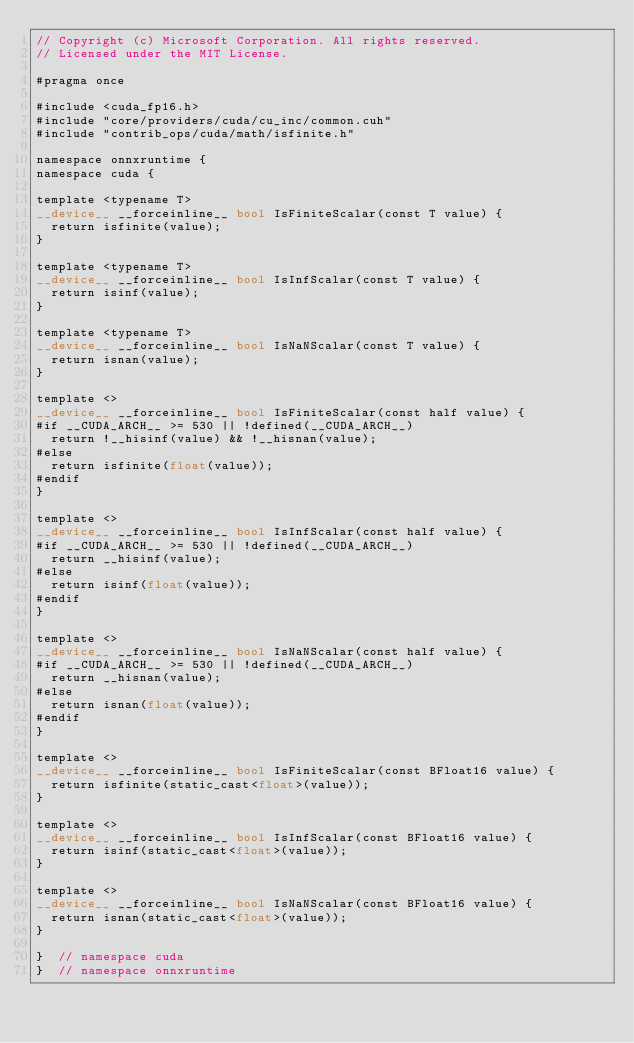<code> <loc_0><loc_0><loc_500><loc_500><_Cuda_>// Copyright (c) Microsoft Corporation. All rights reserved.
// Licensed under the MIT License.

#pragma once

#include <cuda_fp16.h>
#include "core/providers/cuda/cu_inc/common.cuh"
#include "contrib_ops/cuda/math/isfinite.h"

namespace onnxruntime {
namespace cuda {

template <typename T>
__device__ __forceinline__ bool IsFiniteScalar(const T value) {
  return isfinite(value);
}

template <typename T>
__device__ __forceinline__ bool IsInfScalar(const T value) {
  return isinf(value);
}

template <typename T>
__device__ __forceinline__ bool IsNaNScalar(const T value) {
  return isnan(value);
}

template <>
__device__ __forceinline__ bool IsFiniteScalar(const half value) {
#if __CUDA_ARCH__ >= 530 || !defined(__CUDA_ARCH__)
  return !__hisinf(value) && !__hisnan(value);
#else
  return isfinite(float(value));
#endif
}

template <>
__device__ __forceinline__ bool IsInfScalar(const half value) {
#if __CUDA_ARCH__ >= 530 || !defined(__CUDA_ARCH__)
  return __hisinf(value);
#else
  return isinf(float(value));
#endif
}

template <>
__device__ __forceinline__ bool IsNaNScalar(const half value) {
#if __CUDA_ARCH__ >= 530 || !defined(__CUDA_ARCH__)
  return __hisnan(value);
#else
  return isnan(float(value));
#endif
}

template <>
__device__ __forceinline__ bool IsFiniteScalar(const BFloat16 value) {
  return isfinite(static_cast<float>(value));
}

template <>
__device__ __forceinline__ bool IsInfScalar(const BFloat16 value) {
  return isinf(static_cast<float>(value));
}

template <>
__device__ __forceinline__ bool IsNaNScalar(const BFloat16 value) {
  return isnan(static_cast<float>(value));
}

}  // namespace cuda
}  // namespace onnxruntime</code> 